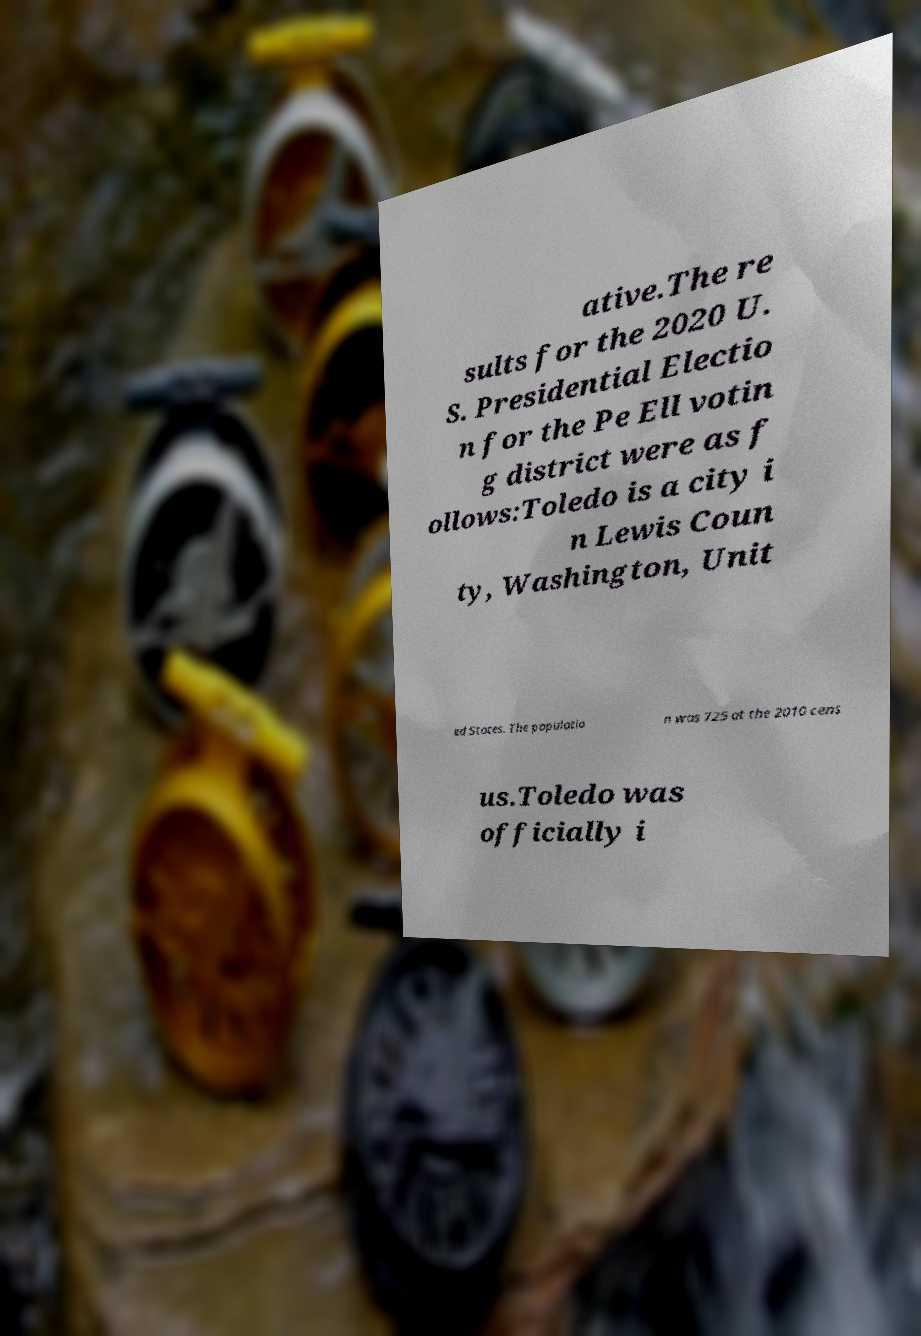Can you accurately transcribe the text from the provided image for me? ative.The re sults for the 2020 U. S. Presidential Electio n for the Pe Ell votin g district were as f ollows:Toledo is a city i n Lewis Coun ty, Washington, Unit ed States. The populatio n was 725 at the 2010 cens us.Toledo was officially i 